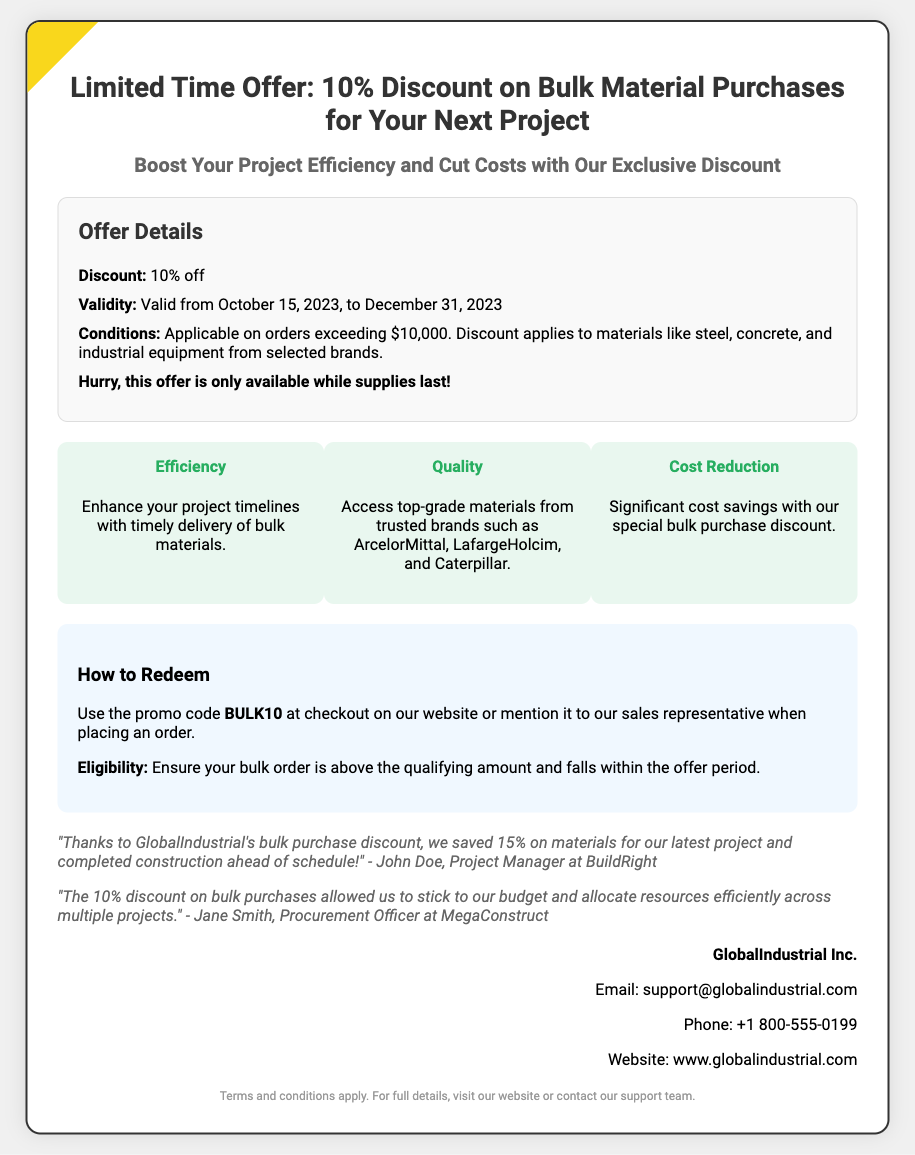What is the discount offered? The document states that the discount is 10% off on bulk material purchases.
Answer: 10% off What is the minimum order amount to qualify for the discount? The document specifies that the discount applies to orders exceeding $10,000.
Answer: $10,000 What is the validity period of the discount? The document mentions that the discount is valid from October 15, 2023, to December 31, 2023.
Answer: October 15, 2023, to December 31, 2023 What is the promo code to redeem the offer? According to the document, the promo code to use at checkout is BULK10.
Answer: BULK10 Which brands are mentioned in the offer? The document lists ArcelorMittal, LafargeHolcim, and Caterpillar as trusted brands for materials.
Answer: ArcelorMittal, LafargeHolcim, Caterpillar What benefit is associated with efficiency? The document states that the efficiency benefit is enhancing project timelines with timely delivery of bulk materials.
Answer: Timely delivery How can a customer redeem the offer? The document explains that customers can redeem the offer by using the promo code or mentioning it to a sales representative.
Answer: Use the promo code or mention to a sales representative Who issued the voucher? The issuer of the voucher is GlobalIndustrial Inc. as stated in the document.
Answer: GlobalIndustrial Inc What do the testimonials in the document highlight? The testimonials highlight the savings and budget adherence achieved through the bulk discount.
Answer: Savings and budget adherence 